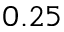<formula> <loc_0><loc_0><loc_500><loc_500>0 . 2 5</formula> 